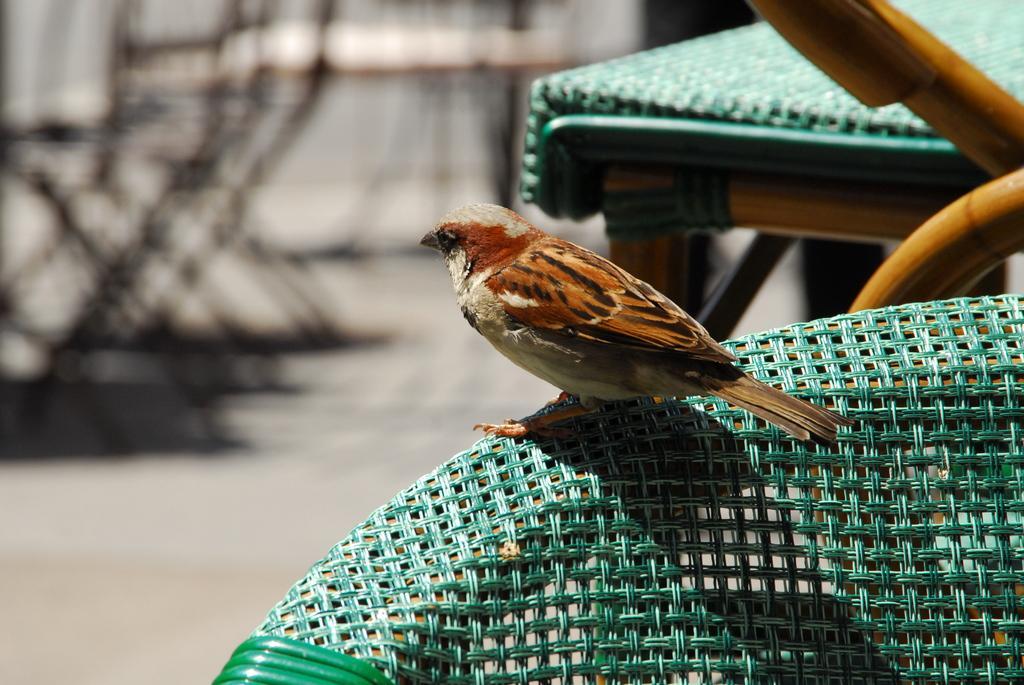In one or two sentences, can you explain what this image depicts? In this image we can see a bird on a chair. We can also see some wooden poles and a table. 